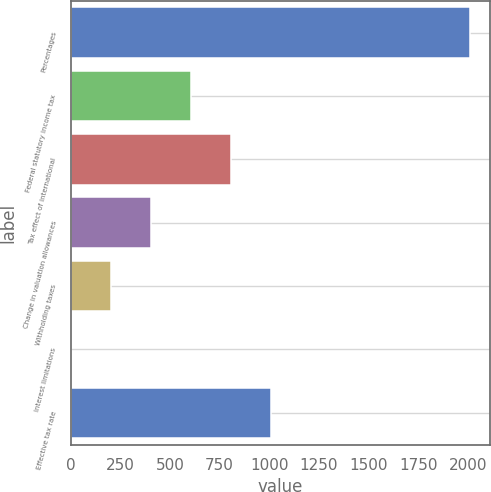Convert chart. <chart><loc_0><loc_0><loc_500><loc_500><bar_chart><fcel>Percentages<fcel>Federal statutory income tax<fcel>Tax effect of international<fcel>Change in valuation allowances<fcel>Withholding taxes<fcel>Interest limitations<fcel>Effective tax rate<nl><fcel>2013<fcel>604.25<fcel>805.5<fcel>403<fcel>201.75<fcel>0.5<fcel>1006.75<nl></chart> 